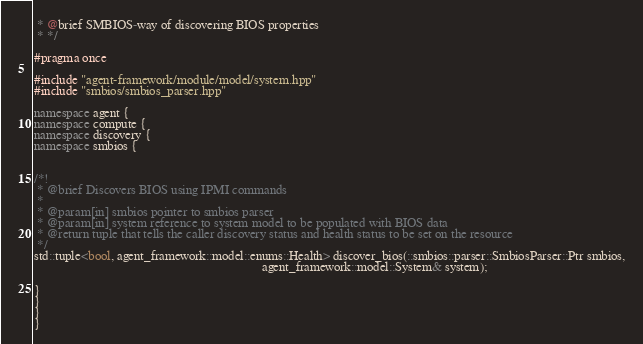Convert code to text. <code><loc_0><loc_0><loc_500><loc_500><_C++_> * @brief SMBIOS-way of discovering BIOS properties
 * */

#pragma once

#include "agent-framework/module/model/system.hpp"
#include "smbios/smbios_parser.hpp"

namespace agent {
namespace compute {
namespace discovery {
namespace smbios {


/*!
 * @brief Discovers BIOS using IPMI commands
 *
 * @param[in] smbios pointer to smbios parser
 * @param[in] system reference to system model to be populated with BIOS data
 * @return tuple that tells the caller discovery status and health status to be set on the resource
 */
std::tuple<bool, agent_framework::model::enums::Health> discover_bios(::smbios::parser::SmbiosParser::Ptr smbios,
                                                                      agent_framework::model::System& system);

}
}
}
}
</code> 